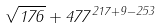Convert formula to latex. <formula><loc_0><loc_0><loc_500><loc_500>\sqrt { 1 7 6 } + 4 7 7 ^ { 2 1 7 + 9 - 2 5 3 }</formula> 